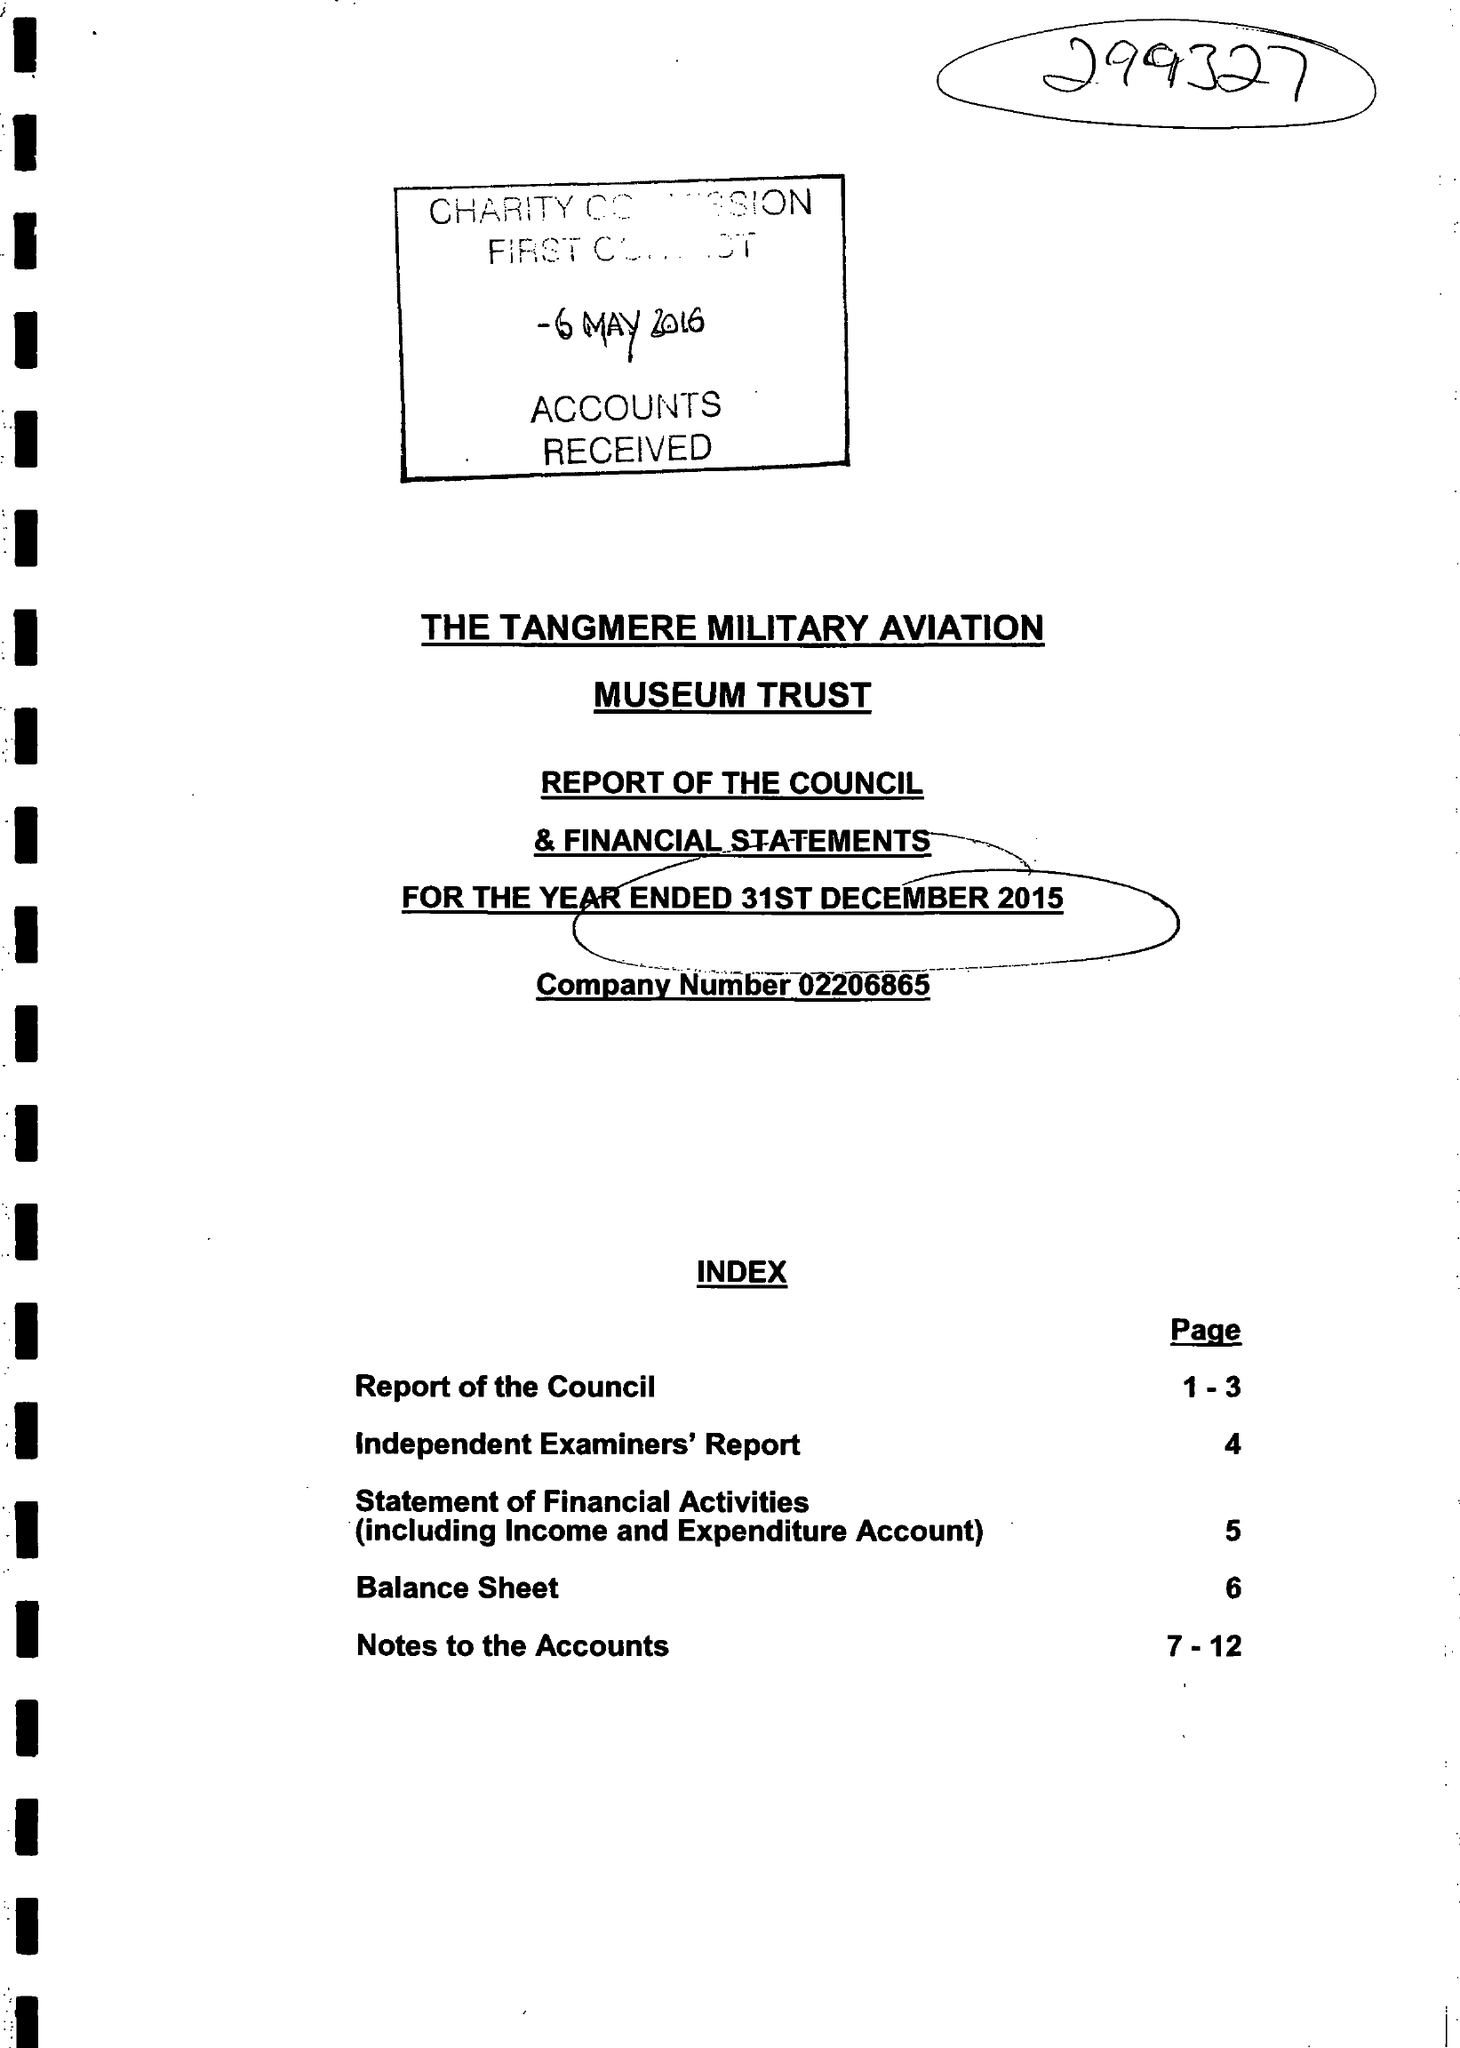What is the value for the address__postcode?
Answer the question using a single word or phrase. None 